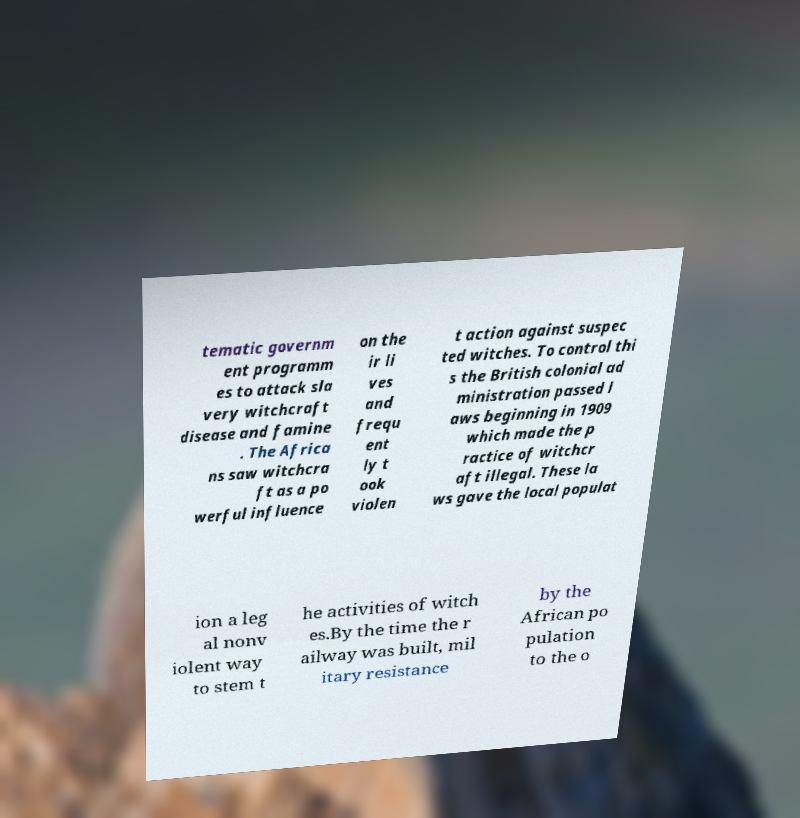Can you accurately transcribe the text from the provided image for me? tematic governm ent programm es to attack sla very witchcraft disease and famine . The Africa ns saw witchcra ft as a po werful influence on the ir li ves and frequ ent ly t ook violen t action against suspec ted witches. To control thi s the British colonial ad ministration passed l aws beginning in 1909 which made the p ractice of witchcr aft illegal. These la ws gave the local populat ion a leg al nonv iolent way to stem t he activities of witch es.By the time the r ailway was built, mil itary resistance by the African po pulation to the o 